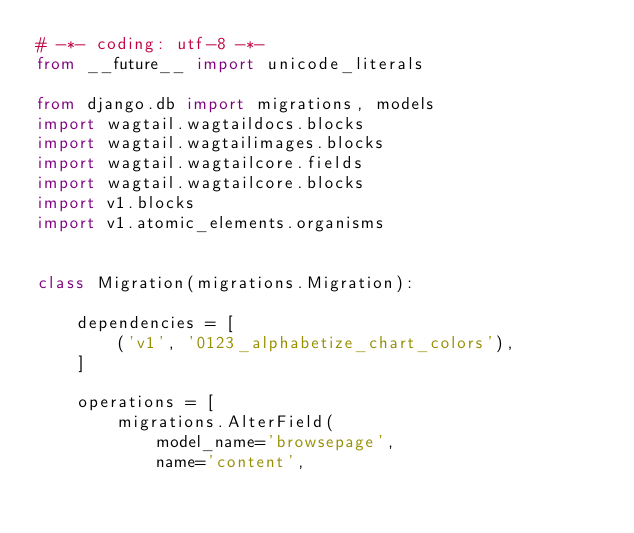<code> <loc_0><loc_0><loc_500><loc_500><_Python_># -*- coding: utf-8 -*-
from __future__ import unicode_literals

from django.db import migrations, models
import wagtail.wagtaildocs.blocks
import wagtail.wagtailimages.blocks
import wagtail.wagtailcore.fields
import wagtail.wagtailcore.blocks
import v1.blocks
import v1.atomic_elements.organisms


class Migration(migrations.Migration):

    dependencies = [
        ('v1', '0123_alphabetize_chart_colors'),
    ]

    operations = [
        migrations.AlterField(
            model_name='browsepage',
            name='content',</code> 